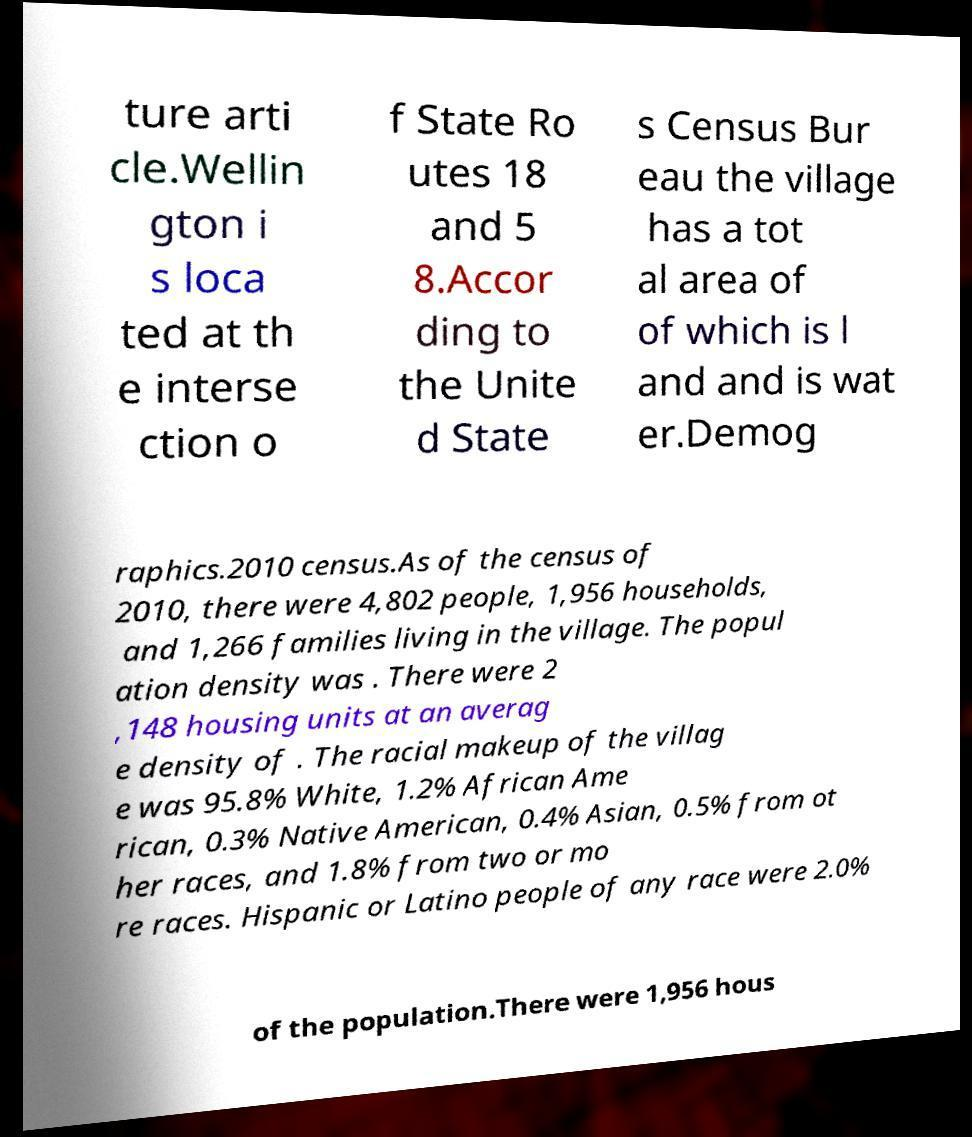There's text embedded in this image that I need extracted. Can you transcribe it verbatim? ture arti cle.Wellin gton i s loca ted at th e interse ction o f State Ro utes 18 and 5 8.Accor ding to the Unite d State s Census Bur eau the village has a tot al area of of which is l and and is wat er.Demog raphics.2010 census.As of the census of 2010, there were 4,802 people, 1,956 households, and 1,266 families living in the village. The popul ation density was . There were 2 ,148 housing units at an averag e density of . The racial makeup of the villag e was 95.8% White, 1.2% African Ame rican, 0.3% Native American, 0.4% Asian, 0.5% from ot her races, and 1.8% from two or mo re races. Hispanic or Latino people of any race were 2.0% of the population.There were 1,956 hous 